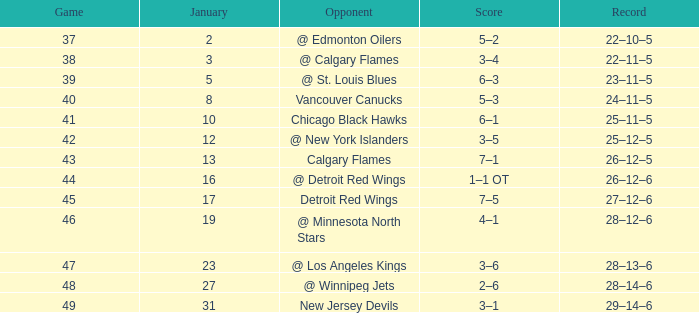How much January has a Record of 26–12–6, and Points smaller than 58? None. 